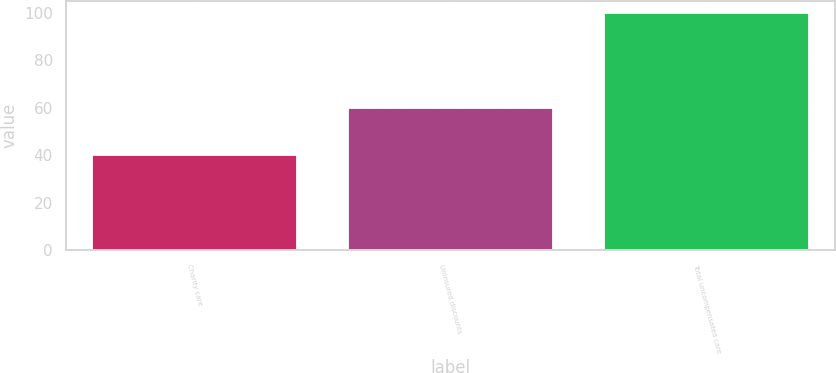<chart> <loc_0><loc_0><loc_500><loc_500><bar_chart><fcel>Charity care<fcel>Uninsured discounts<fcel>Total uncompensated care<nl><fcel>40<fcel>60<fcel>100<nl></chart> 